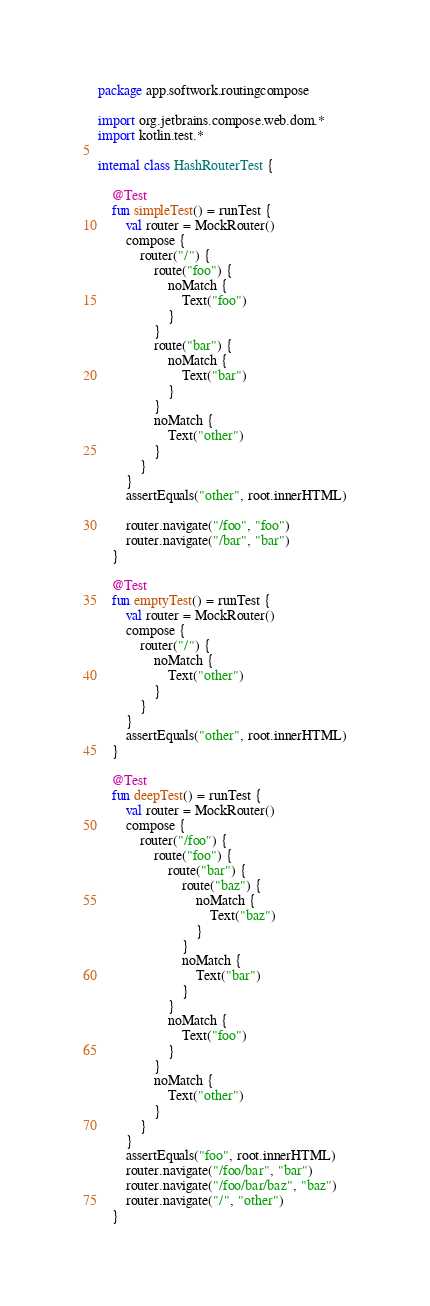Convert code to text. <code><loc_0><loc_0><loc_500><loc_500><_Kotlin_>package app.softwork.routingcompose

import org.jetbrains.compose.web.dom.*
import kotlin.test.*

internal class HashRouterTest {

    @Test
    fun simpleTest() = runTest {
        val router = MockRouter()
        compose {
            router("/") {
                route("foo") {
                    noMatch {
                        Text("foo")
                    }
                }
                route("bar") {
                    noMatch {
                        Text("bar")
                    }
                }
                noMatch {
                    Text("other")
                }
            }
        }
        assertEquals("other", root.innerHTML)

        router.navigate("/foo", "foo")
        router.navigate("/bar", "bar")
    }

    @Test
    fun emptyTest() = runTest {
        val router = MockRouter()
        compose {
            router("/") {
                noMatch {
                    Text("other")
                }
            }
        }
        assertEquals("other", root.innerHTML)
    }

    @Test
    fun deepTest() = runTest {
        val router = MockRouter()
        compose {
            router("/foo") {
                route("foo") {
                    route("bar") {
                        route("baz") {
                            noMatch {
                                Text("baz")
                            }
                        }
                        noMatch {
                            Text("bar")
                        }
                    }
                    noMatch {
                        Text("foo")
                    }
                }
                noMatch {
                    Text("other")
                }
            }
        }
        assertEquals("foo", root.innerHTML)
        router.navigate("/foo/bar", "bar")
        router.navigate("/foo/bar/baz", "baz")
        router.navigate("/", "other")
    }
</code> 